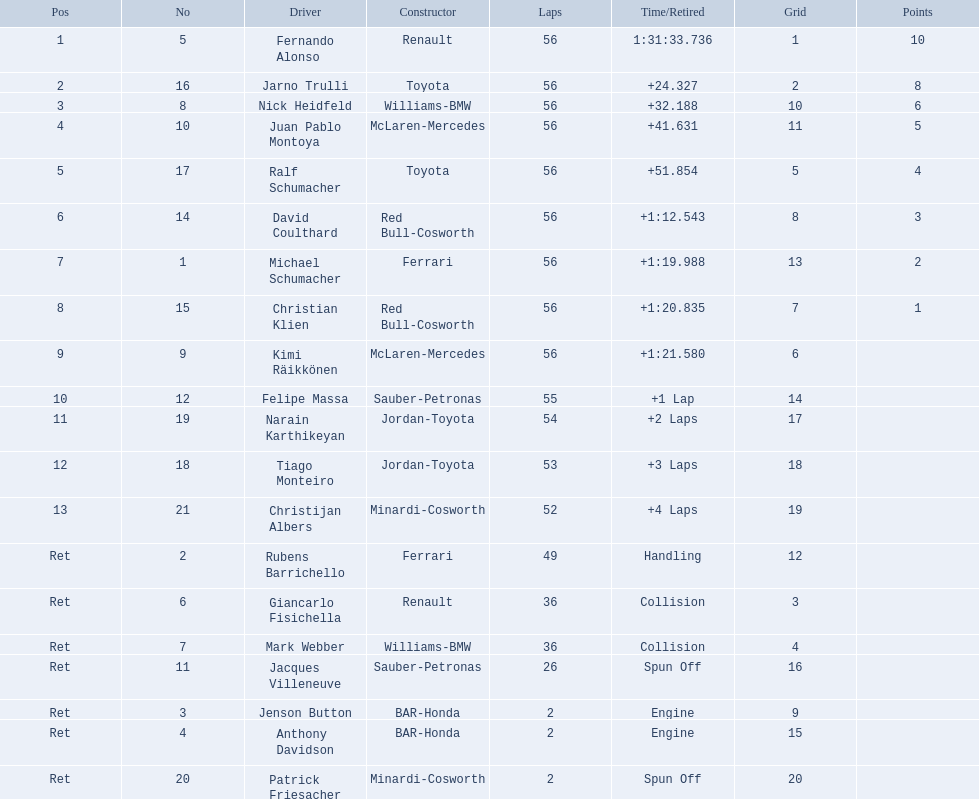What place did fernando alonso finish? 1. How long did it take alonso to finish the race? 1:31:33.736. Who took part in the 2005 malaysian grand prix? Fernando Alonso, Jarno Trulli, Nick Heidfeld, Juan Pablo Montoya, Ralf Schumacher, David Coulthard, Michael Schumacher, Christian Klien, Kimi Räikkönen, Felipe Massa, Narain Karthikeyan, Tiago Monteiro, Christijan Albers, Rubens Barrichello, Giancarlo Fisichella, Mark Webber, Jacques Villeneuve, Jenson Button, Anthony Davidson, Patrick Friesacher. What were their end times? 1:31:33.736, +24.327, +32.188, +41.631, +51.854, +1:12.543, +1:19.988, +1:20.835, +1:21.580, +1 Lap, +2 Laps, +3 Laps, +4 Laps, Handling, Collision, Collision, Spun Off, Engine, Engine, Spun Off. What was fernando alonso's end time? 1:31:33.736. 